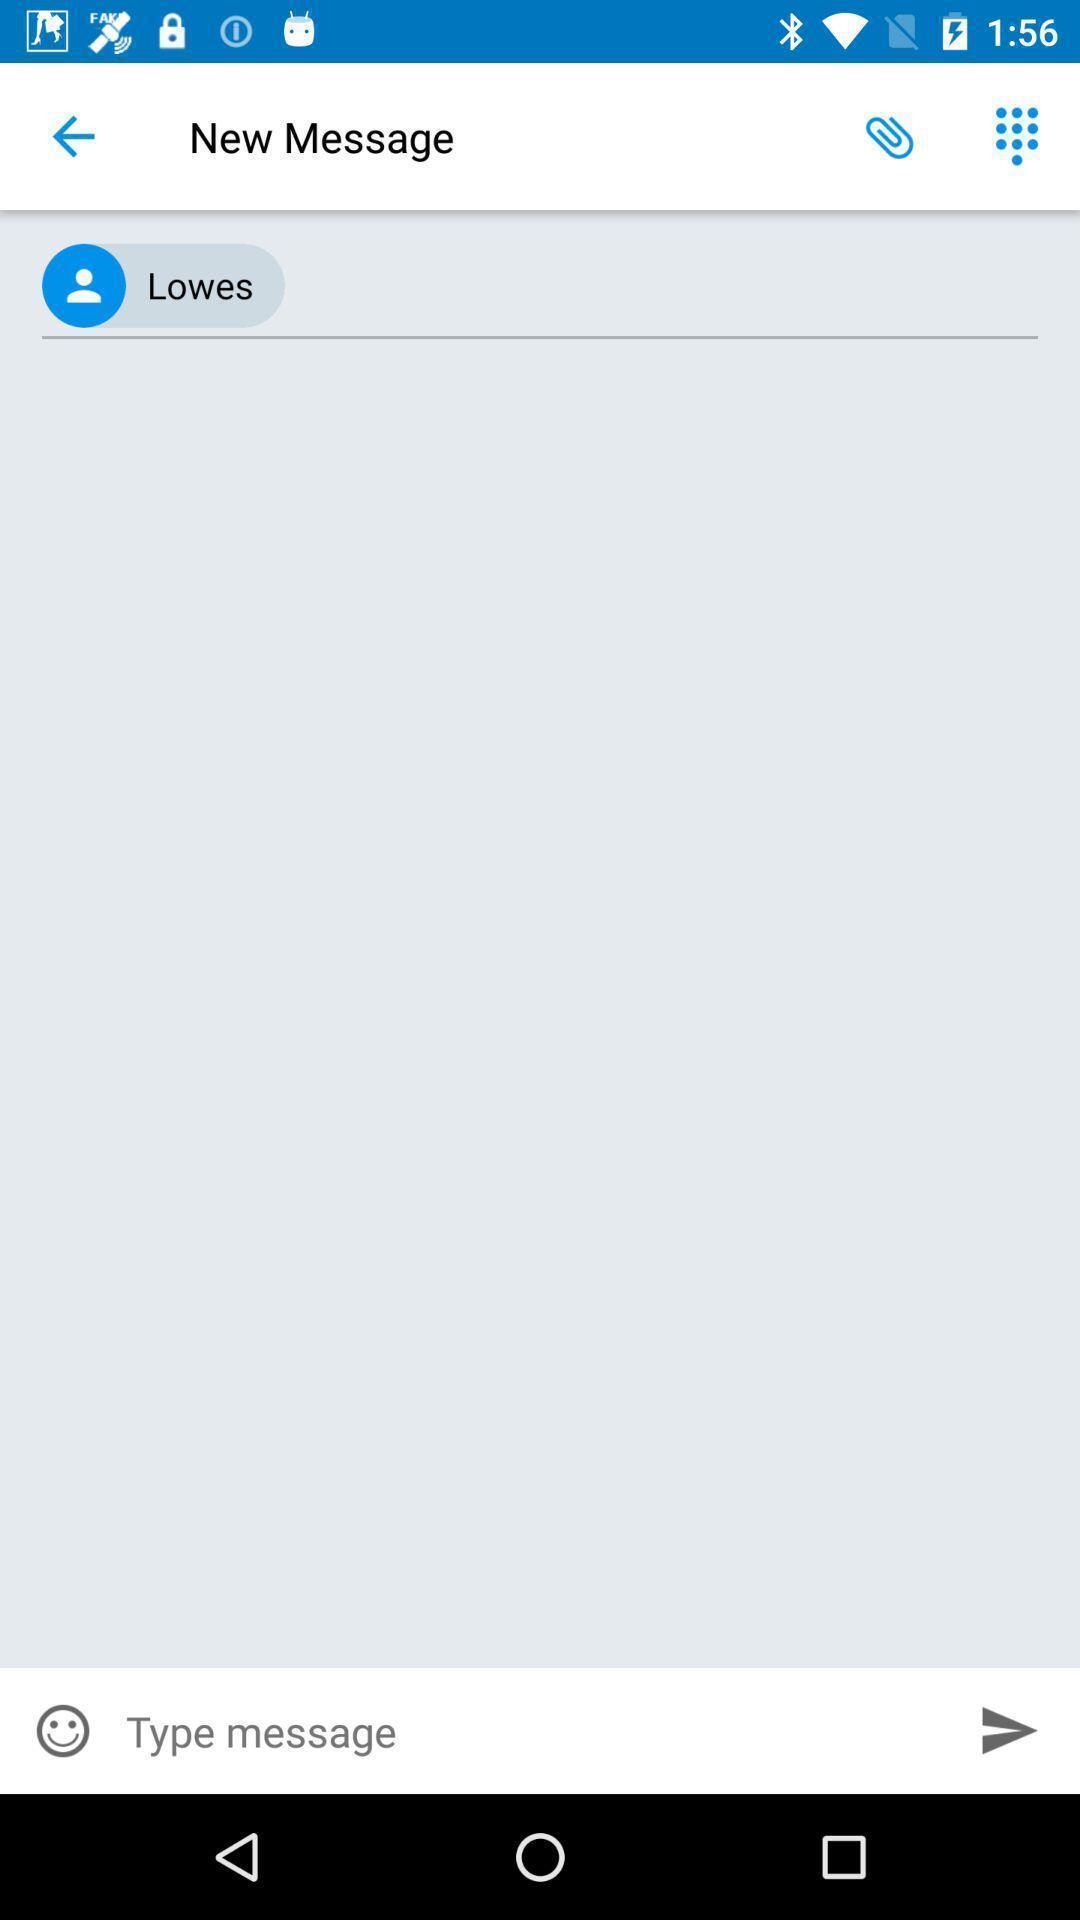Describe this image in words. Text message bar in messaging app. 